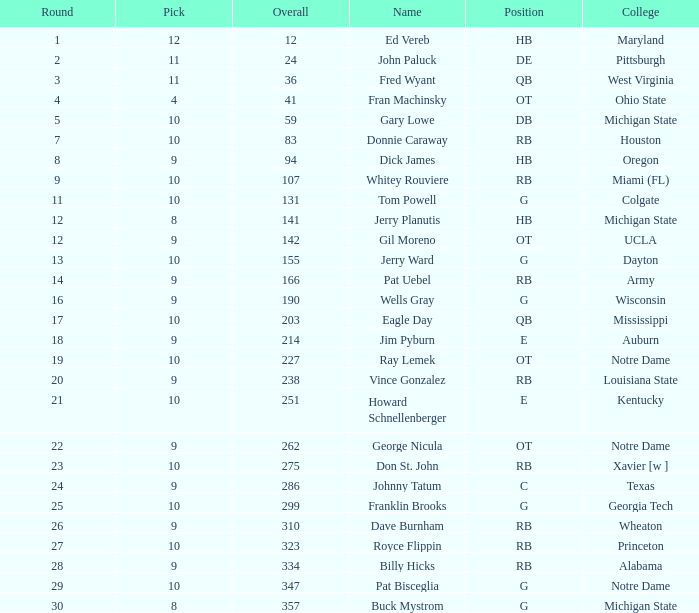What is the highest round number for donnie caraway? 7.0. 